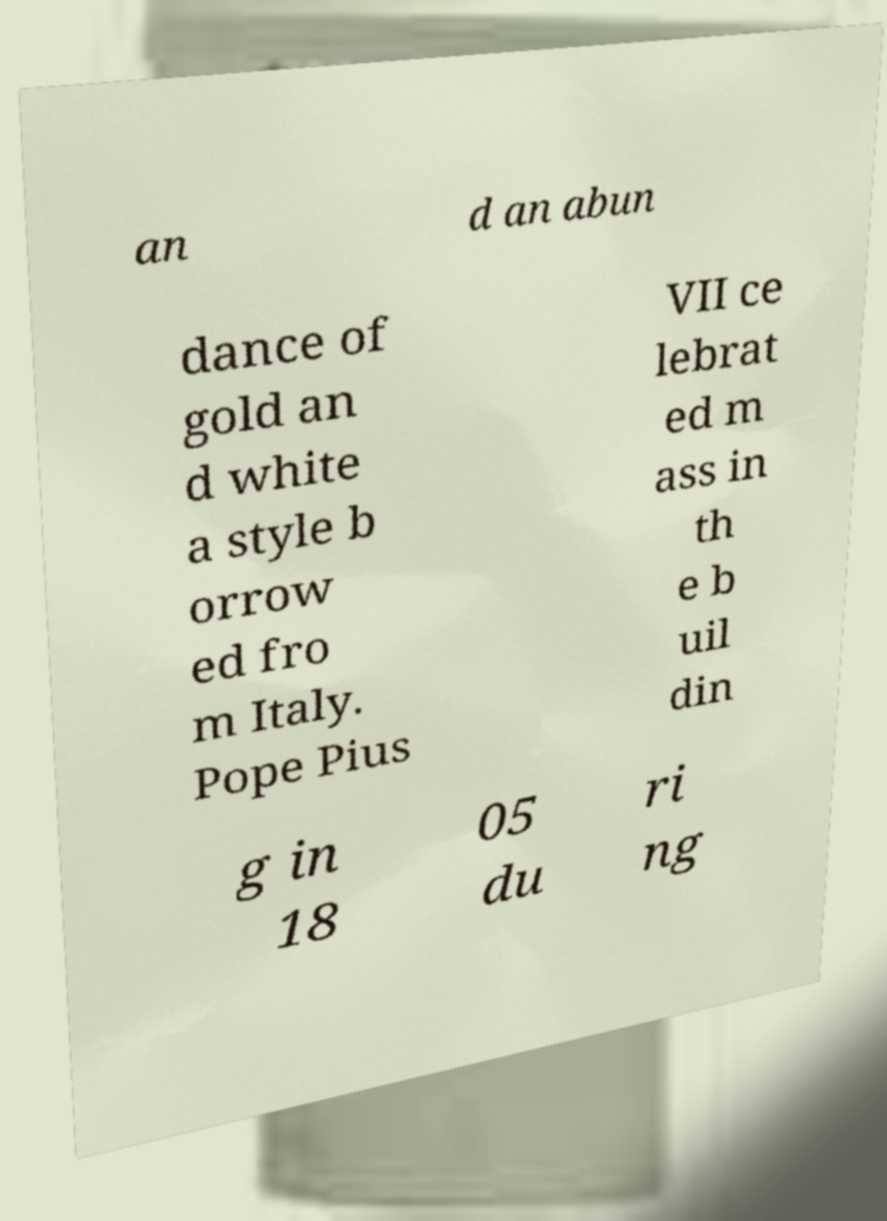Please identify and transcribe the text found in this image. an d an abun dance of gold an d white a style b orrow ed fro m Italy. Pope Pius VII ce lebrat ed m ass in th e b uil din g in 18 05 du ri ng 